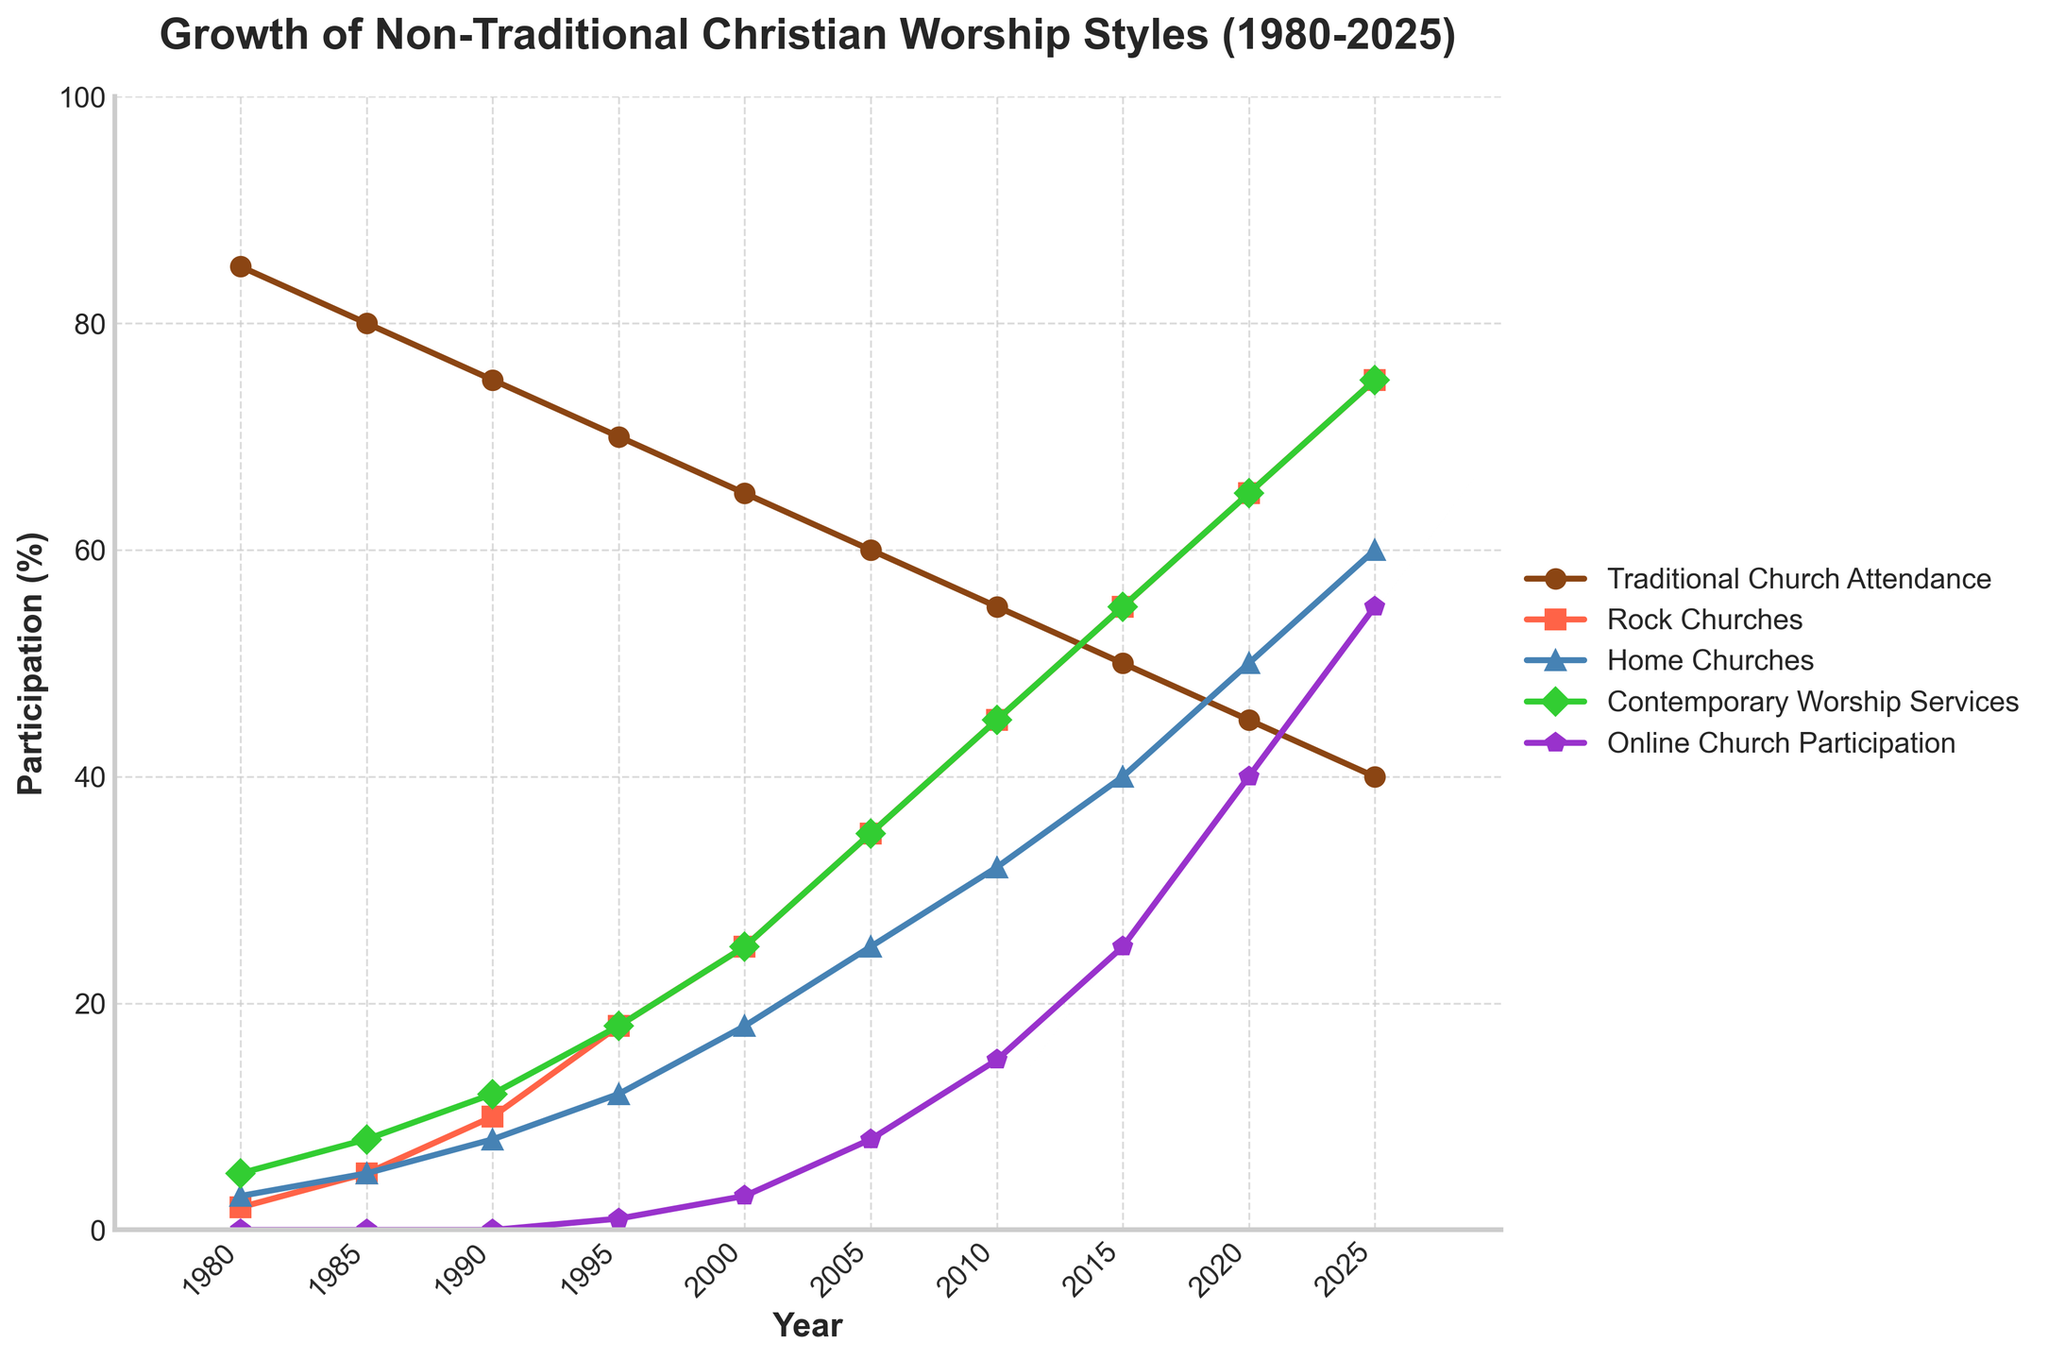What is the attendance percentage of Traditional Church Attendance in 2010? Look at the data point for Traditional Church Attendance in the year 2010 on the x-axis, which is 55%.
Answer: 55% Which worship style surpassed 50% participation first between Rock Churches and Online Church Participation? Identify the data points where both Rock Churches and Online Church Participation reach 50%. Rock Churches reached 50% first in 2015, while Online Church Participation reached 50% in 2020.
Answer: Rock Churches How much did Home Churches grow from 1980 to 2025? Calculate the difference in participation of Home Churches from 1980 to 2025. In 1980, it was 3%, and in 2025, it is 60%. Therefore, 60% - 3% = 57%.
Answer: 57% In which year did Contemporary Worship Services equal Traditional Church Attendance? Find the point where the lines for Contemporary Worship Services and Traditional Church Attendance intersect. This happens in 2020, where both have a participation of 45%.
Answer: 2020 How many worship styles had a participation rate below 10% in 1985? Identify all the worship styles in 1985 and count the ones below 10%. Those are Rock Churches (5%), Home Churches (5%), Contemporary Worship Services (8%), and Online Church Participation (0%). Only Traditional Church Attendance is above 10%, making the total four.
Answer: 4 Compare the growth rates of Home Churches and Online Church Participation from 1995 to 2005. Which grew faster? Check the differences for each worship style between 1995 and 2005. Home Churches grew from 12% to 25% (an increase of 13%), while Online Church Participation grew from 1% to 8% (an increase of 7%).
Answer: Home Churches What is the highest percentage of participation achieved by any worship style by 2025? From the data, identify the highest value across all worship styles in the year 2025. The highest value is 75%, achieved by Rock Churches and Contemporary Worship Services.
Answer: 75% Which worship style showed the most consistent growth over the years? Examine the slope and growth trends for each worship style line. Rock Churches shows a consistent and steep growth from 1980 to 2025 without major fluctuations.
Answer: Rock Churches By how much did participation in Contemporary Worship Services increase between 1980 and 2015? Calculate the difference in percentages: 55% (in 2015) minus 5% (in 1980) gives an increase of 50%.
Answer: 50% What visual feature differentiates Traditional Church Attendance from other worship styles? Traditional Church Attendance is represented by a brown line ('#8B4513') with circle markers. It is unique because it consistently declines over time, unlike other styles which mostly increase.
Answer: Consistently declining trend and unique brown line 